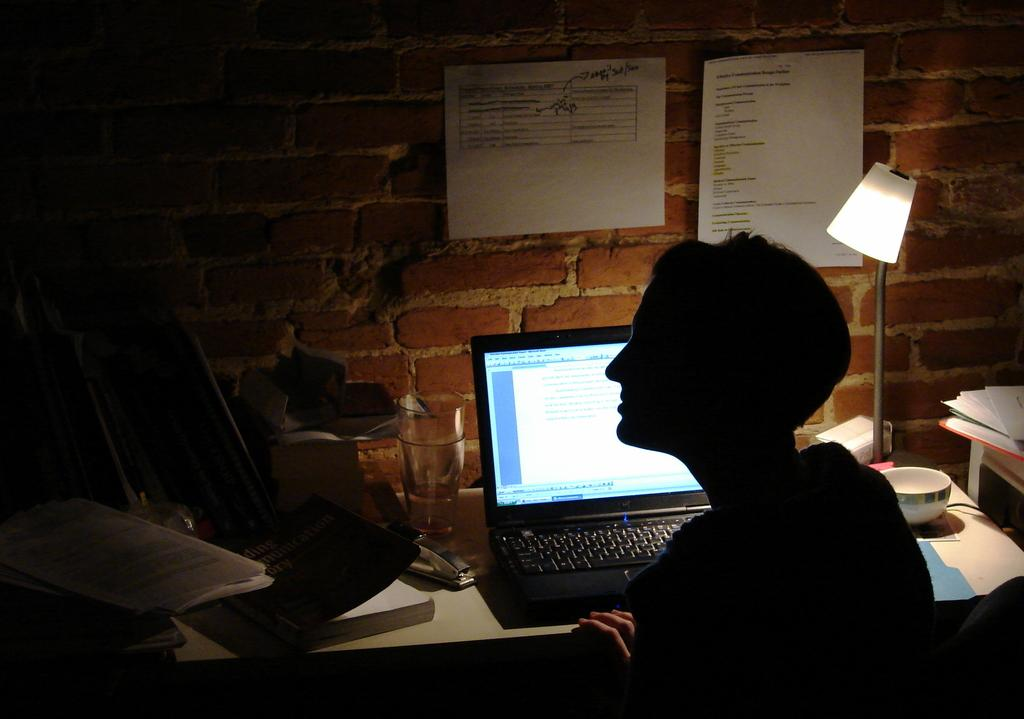What type of wall is visible in the image? There is a brick wall in the image. What items can be seen on the table in the image? There is a lamp, a bowl, a laptop, and a book on the table in the image. What is the person in the image doing? The person is sitting on a chair in the image. Are there any papers visible in the image? Yes, there are papers in the image, both in the person's hands and on the table. How many cakes are being served on the table in the image? There are no cakes present in the image; the table contains a lamp, a bowl, a laptop, and a book. Are there any dogs visible in the image? No, there are no dogs present in the image. 